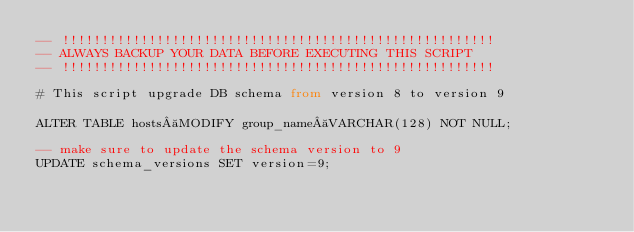<code> <loc_0><loc_0><loc_500><loc_500><_SQL_>-- !!!!!!!!!!!!!!!!!!!!!!!!!!!!!!!!!!!!!!!!!!!!!!!!!!!!!!!
-- ALWAYS BACKUP YOUR DATA BEFORE EXECUTING THIS SCRIPT
-- !!!!!!!!!!!!!!!!!!!!!!!!!!!!!!!!!!!!!!!!!!!!!!!!!!!!!!!

# This script upgrade DB schema from version 8 to version 9

ALTER TABLE hosts MODIFY group_name VARCHAR(128) NOT NULL;

-- make sure to update the schema version to 9
UPDATE schema_versions SET version=9;
</code> 